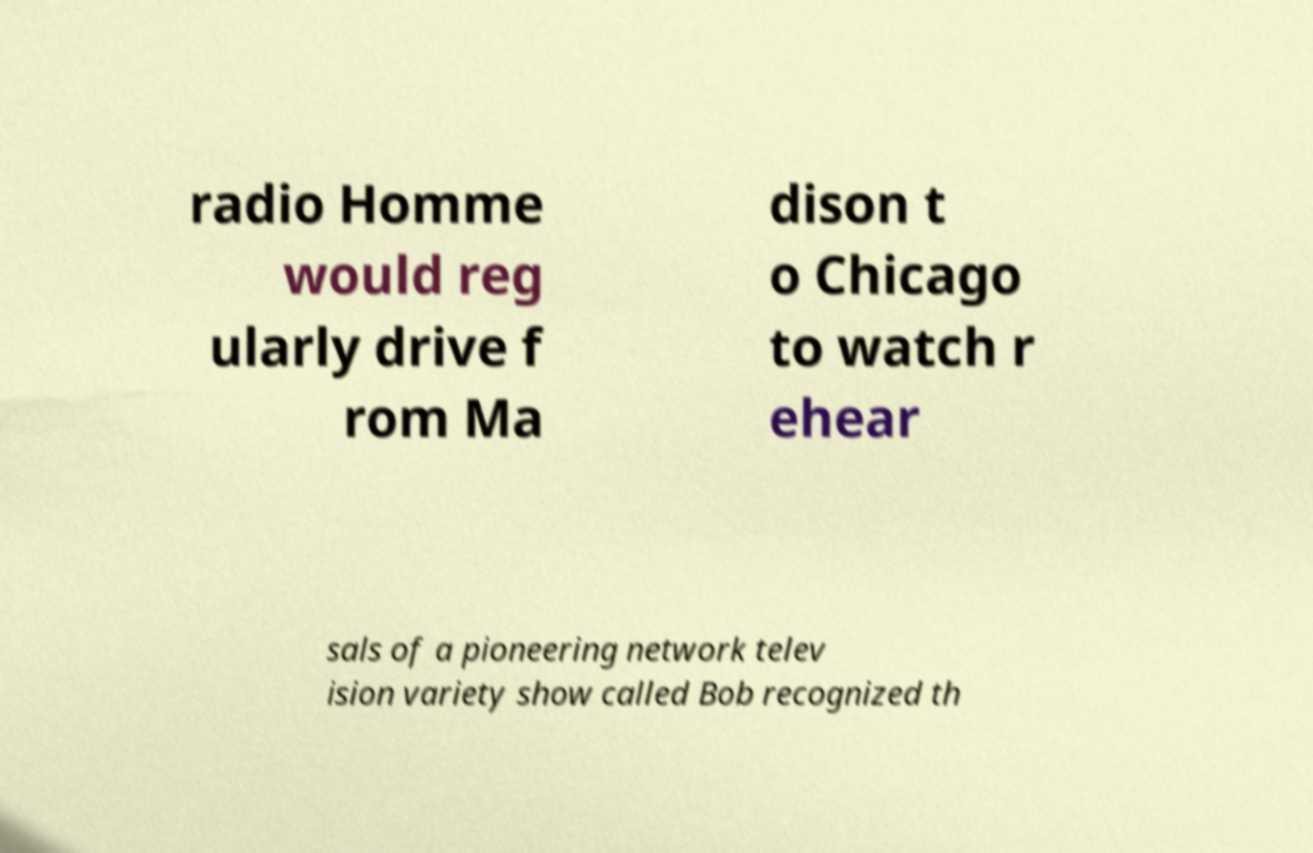Can you accurately transcribe the text from the provided image for me? radio Homme would reg ularly drive f rom Ma dison t o Chicago to watch r ehear sals of a pioneering network telev ision variety show called Bob recognized th 